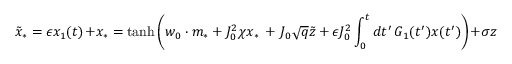Convert formula to latex. <formula><loc_0><loc_0><loc_500><loc_500>\tilde { x } _ { * } = \epsilon x _ { 1 } ( t ) + x _ { * } = t a n h \left ( w _ { 0 } \cdot m _ { * } + J _ { 0 } ^ { 2 } \chi x _ { * } \, + \, J _ { 0 } \sqrt { q } \tilde { z } + \epsilon J _ { 0 } ^ { 2 } \int _ { 0 } ^ { t } d t ^ { \prime } \, G _ { 1 } ( t ^ { \prime } ) x ( t ^ { \prime } ) \right ) + \sigma z</formula> 